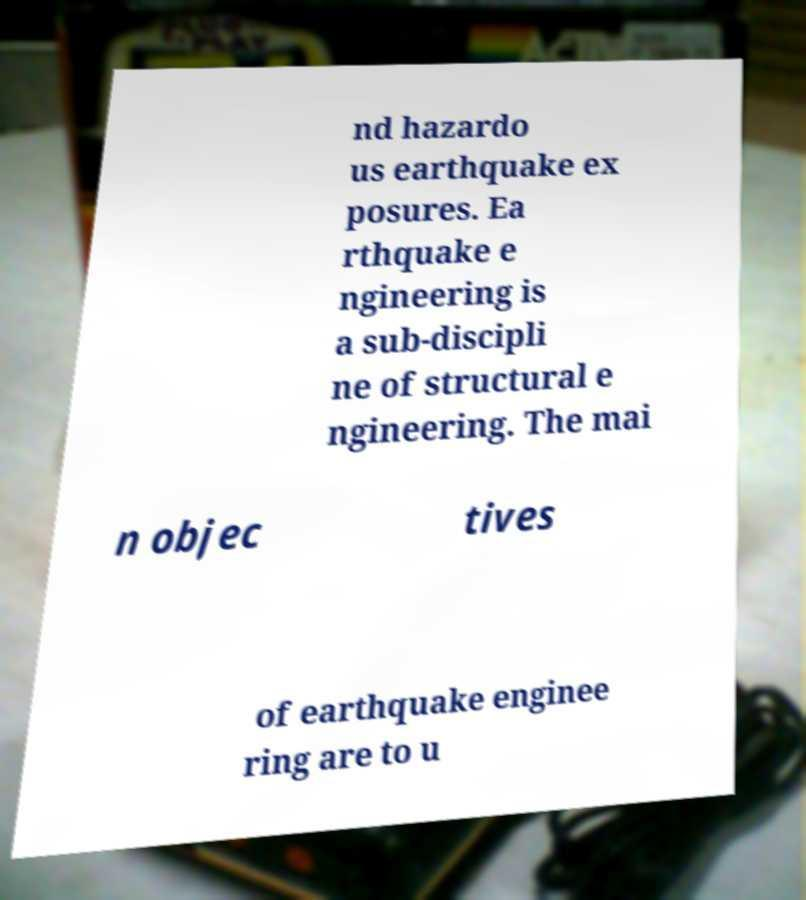Please identify and transcribe the text found in this image. nd hazardo us earthquake ex posures. Ea rthquake e ngineering is a sub-discipli ne of structural e ngineering. The mai n objec tives of earthquake enginee ring are to u 